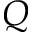Convert formula to latex. <formula><loc_0><loc_0><loc_500><loc_500>Q</formula> 